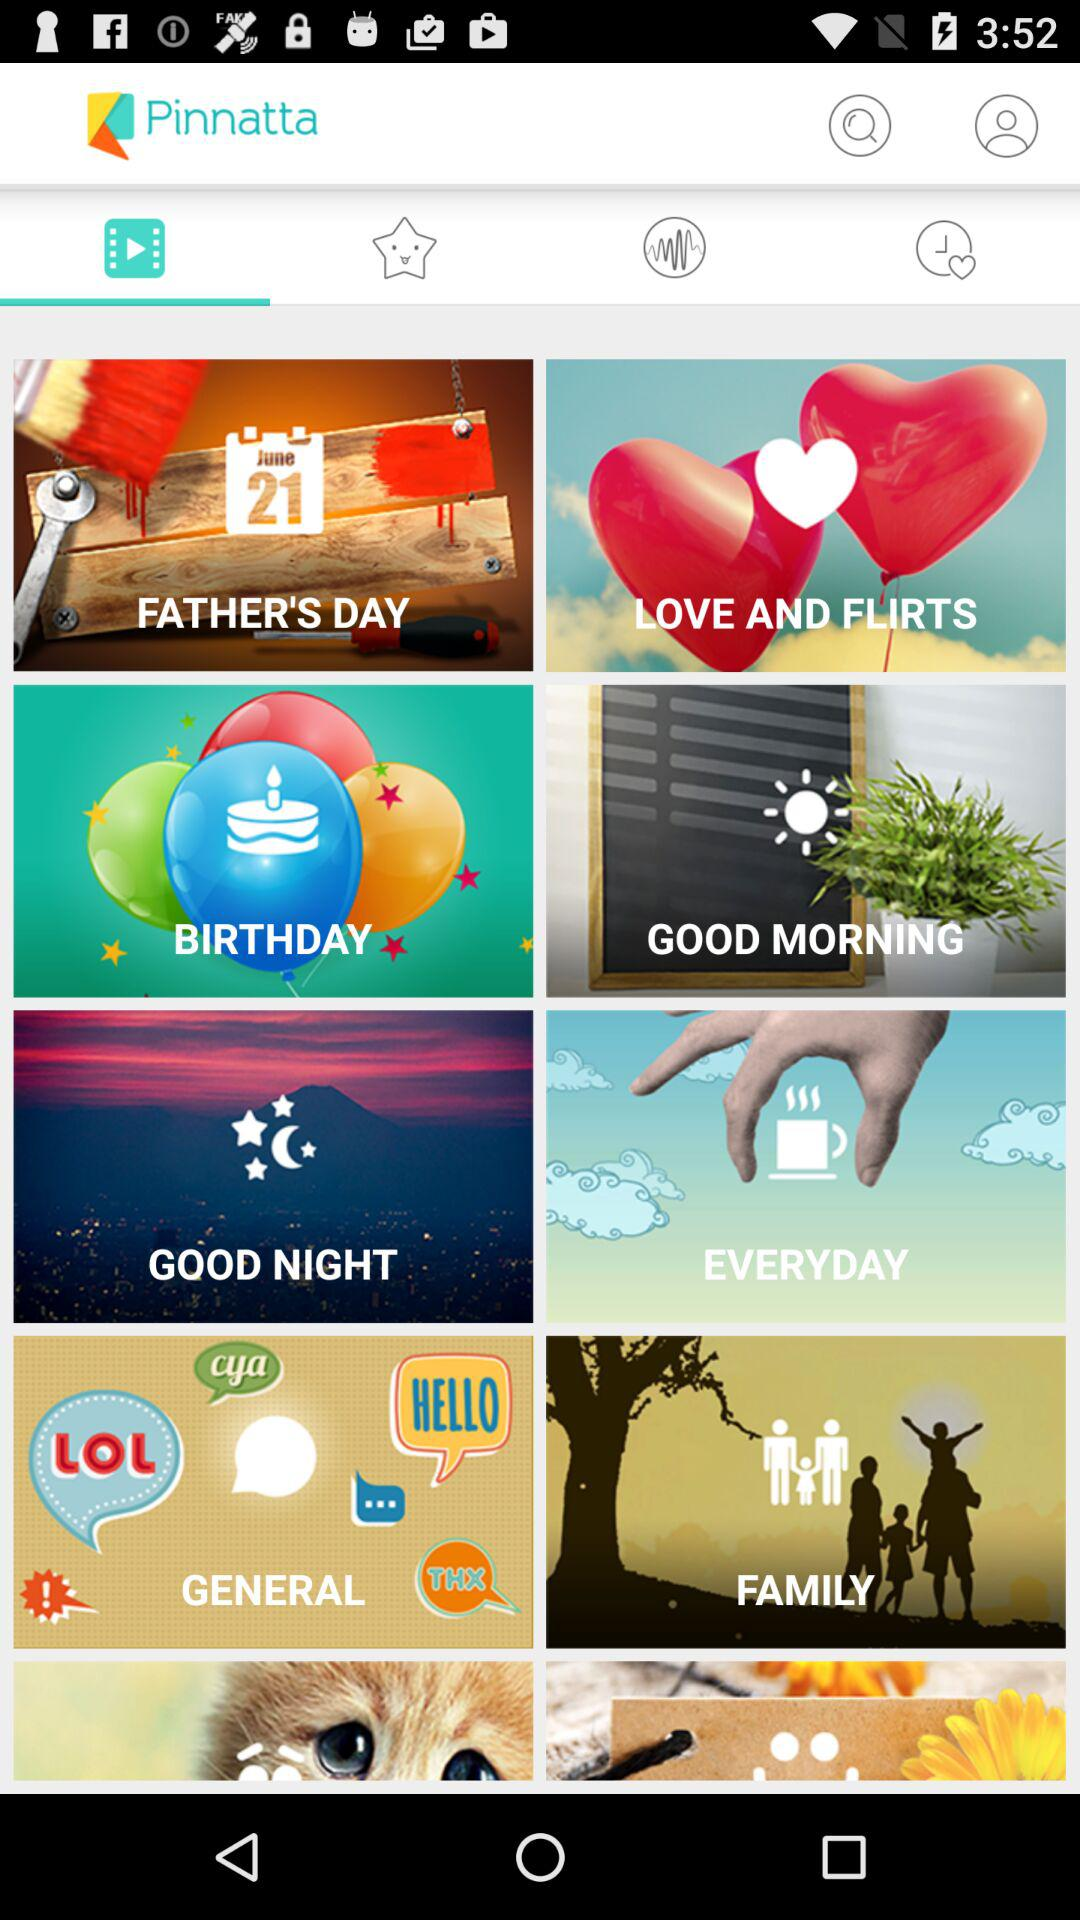What is the name of the application? The name of the application is "Pinnatta". 